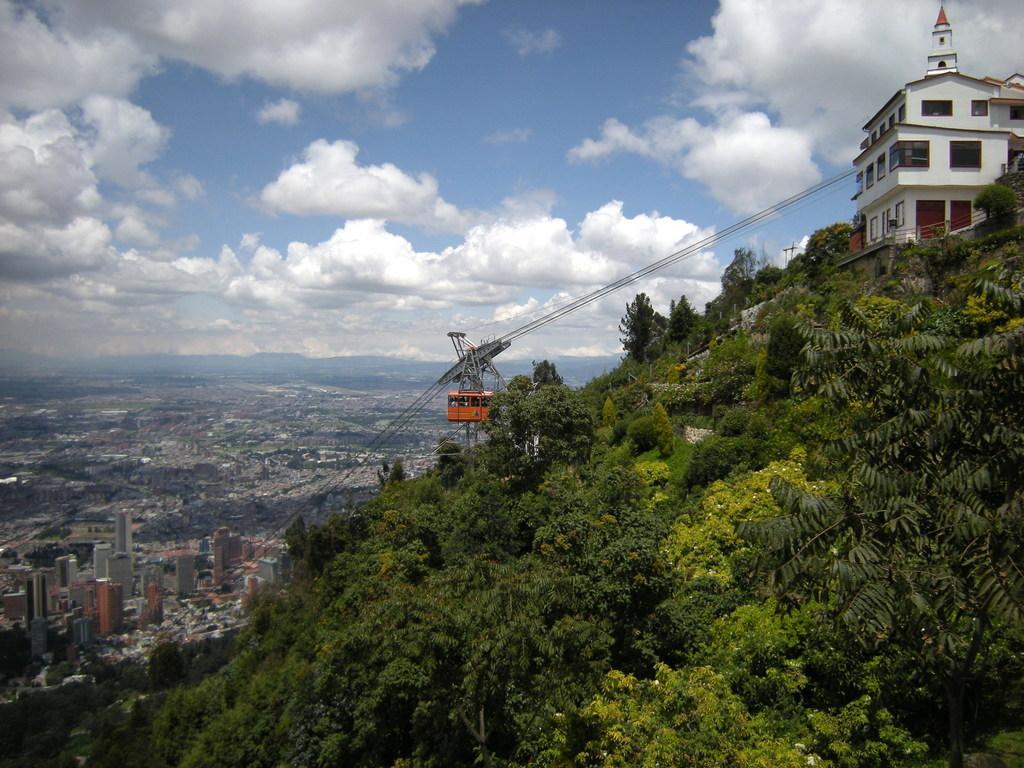Describe this image in one or two sentences. In the foreground of the picture I can see the trees. There is a building on the top right side of the picture. I can see the cable car. In the background, I can see the tower buildings. There are clouds in the sky. 